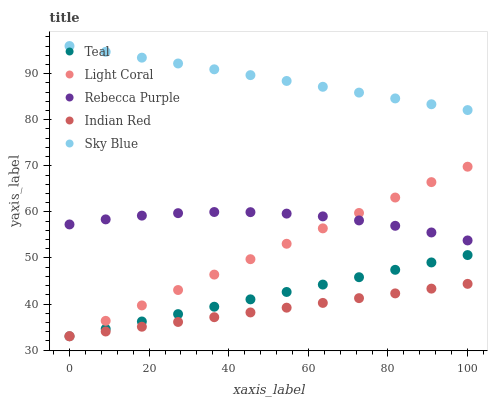Does Indian Red have the minimum area under the curve?
Answer yes or no. Yes. Does Sky Blue have the maximum area under the curve?
Answer yes or no. Yes. Does Sky Blue have the minimum area under the curve?
Answer yes or no. No. Does Indian Red have the maximum area under the curve?
Answer yes or no. No. Is Sky Blue the smoothest?
Answer yes or no. Yes. Is Rebecca Purple the roughest?
Answer yes or no. Yes. Is Indian Red the smoothest?
Answer yes or no. No. Is Indian Red the roughest?
Answer yes or no. No. Does Light Coral have the lowest value?
Answer yes or no. Yes. Does Sky Blue have the lowest value?
Answer yes or no. No. Does Sky Blue have the highest value?
Answer yes or no. Yes. Does Indian Red have the highest value?
Answer yes or no. No. Is Teal less than Rebecca Purple?
Answer yes or no. Yes. Is Sky Blue greater than Teal?
Answer yes or no. Yes. Does Indian Red intersect Light Coral?
Answer yes or no. Yes. Is Indian Red less than Light Coral?
Answer yes or no. No. Is Indian Red greater than Light Coral?
Answer yes or no. No. Does Teal intersect Rebecca Purple?
Answer yes or no. No. 